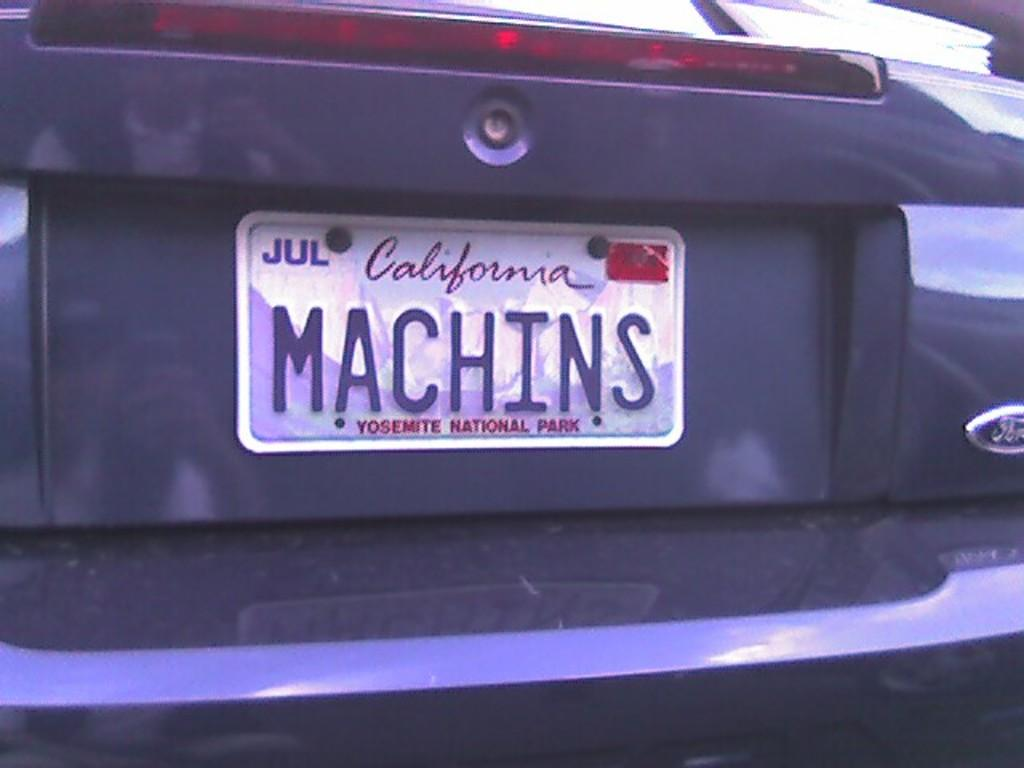<image>
Present a compact description of the photo's key features. A gray car with a California plate says MACHINS on the license plate. 